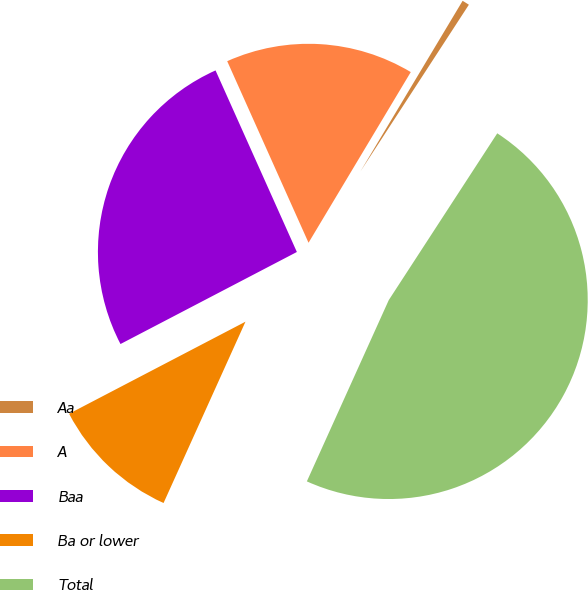Convert chart to OTSL. <chart><loc_0><loc_0><loc_500><loc_500><pie_chart><fcel>Aa<fcel>A<fcel>Baa<fcel>Ba or lower<fcel>Total<nl><fcel>0.59%<fcel>15.29%<fcel>25.95%<fcel>10.59%<fcel>47.57%<nl></chart> 